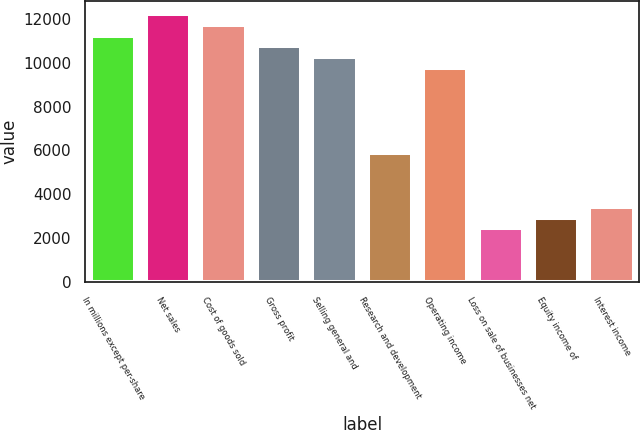<chart> <loc_0><loc_0><loc_500><loc_500><bar_chart><fcel>In millions except per-share<fcel>Net sales<fcel>Cost of goods sold<fcel>Gross profit<fcel>Selling general and<fcel>Research and development<fcel>Operating income<fcel>Loss on sale of businesses net<fcel>Equity income of<fcel>Interest income<nl><fcel>11246.5<fcel>12224.4<fcel>11735.4<fcel>10757.5<fcel>10268.5<fcel>5867.91<fcel>9779.59<fcel>2445.19<fcel>2934.15<fcel>3423.11<nl></chart> 